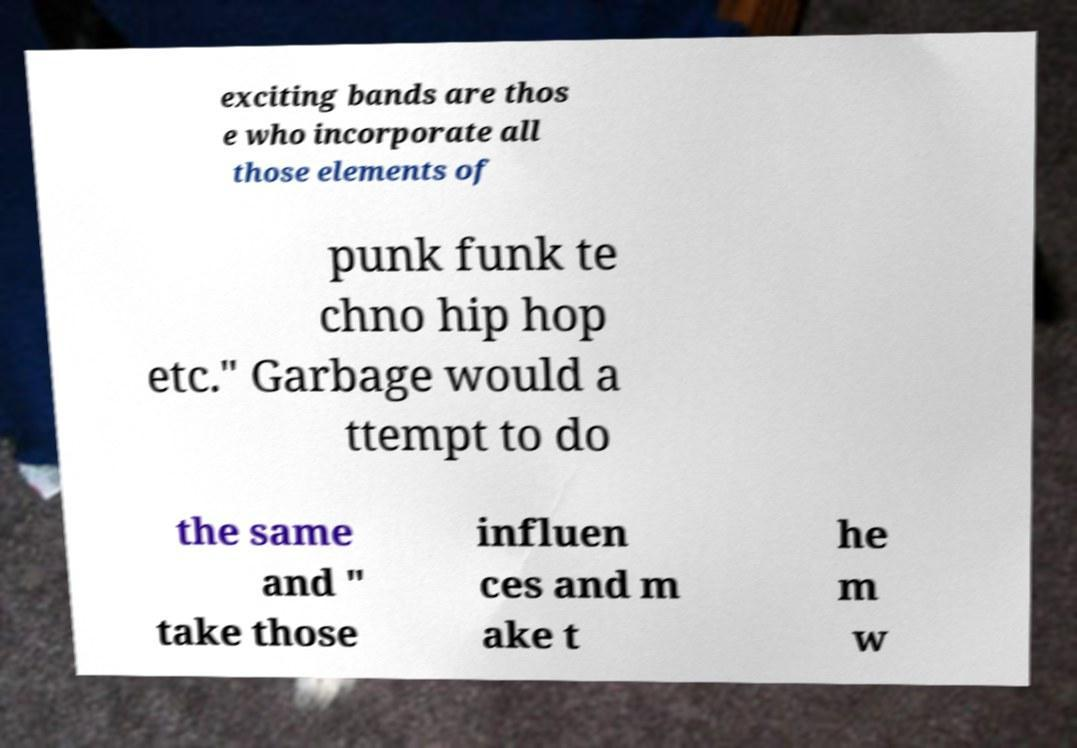For documentation purposes, I need the text within this image transcribed. Could you provide that? exciting bands are thos e who incorporate all those elements of punk funk te chno hip hop etc." Garbage would a ttempt to do the same and " take those influen ces and m ake t he m w 